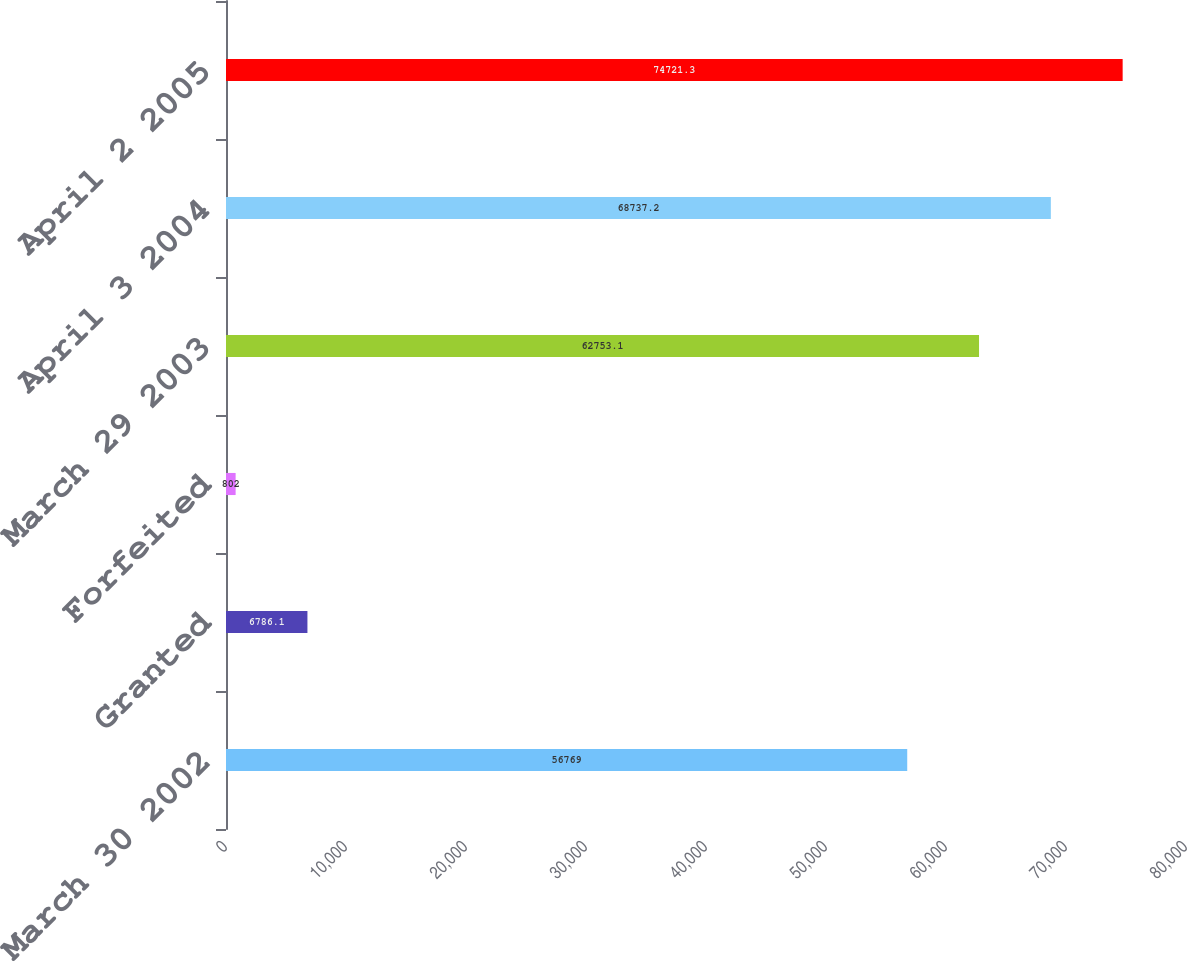Convert chart. <chart><loc_0><loc_0><loc_500><loc_500><bar_chart><fcel>March 30 2002<fcel>Granted<fcel>Forfeited<fcel>March 29 2003<fcel>April 3 2004<fcel>April 2 2005<nl><fcel>56769<fcel>6786.1<fcel>802<fcel>62753.1<fcel>68737.2<fcel>74721.3<nl></chart> 